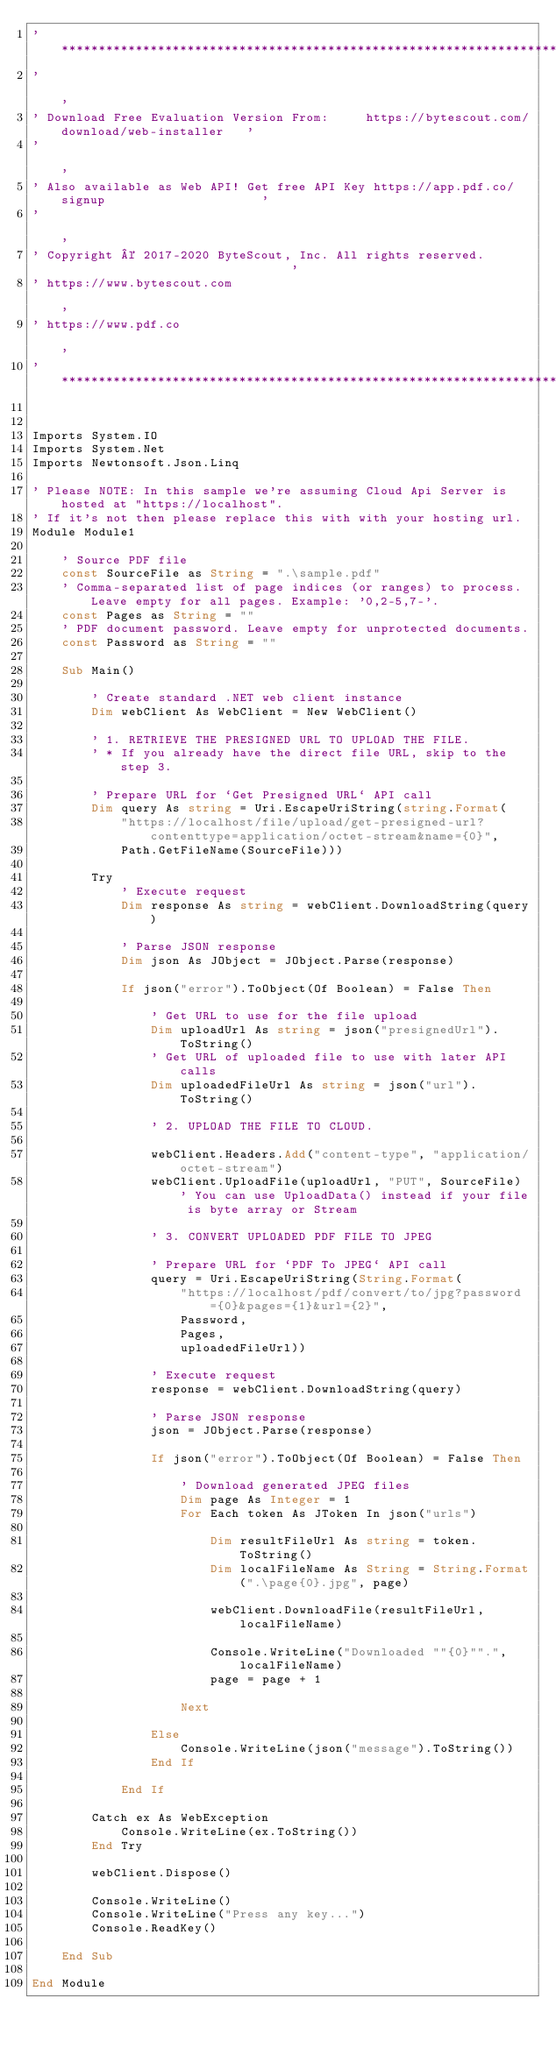Convert code to text. <code><loc_0><loc_0><loc_500><loc_500><_VisualBasic_>'*******************************************************************************************'
'                                                                                           '
' Download Free Evaluation Version From:     https://bytescout.com/download/web-installer   '
'                                                                                           '
' Also available as Web API! Get free API Key https://app.pdf.co/signup                     '
'                                                                                           '
' Copyright © 2017-2020 ByteScout, Inc. All rights reserved.                                '
' https://www.bytescout.com                                                                 '
' https://www.pdf.co                                                                        '
'*******************************************************************************************'


Imports System.IO
Imports System.Net
Imports Newtonsoft.Json.Linq

' Please NOTE: In this sample we're assuming Cloud Api Server is hosted at "https://localhost". 
' If it's not then please replace this with with your hosting url.
Module Module1

 	' Source PDF file
	const SourceFile as String = ".\sample.pdf"
	' Comma-separated list of page indices (or ranges) to process. Leave empty for all pages. Example: '0,2-5,7-'.
	const Pages as String = ""
	' PDF document password. Leave empty for unprotected documents.
	const Password as String = ""
	
	Sub Main()

		' Create standard .NET web client instance
		Dim webClient As WebClient = New WebClient()

		' 1. RETRIEVE THE PRESIGNED URL TO UPLOAD THE FILE.
		' * If you already have the direct file URL, skip to the step 3.

		' Prepare URL for `Get Presigned URL` API call
		Dim query As string = Uri.EscapeUriString(string.Format(
			"https://localhost/file/upload/get-presigned-url?contenttype=application/octet-stream&name={0}", 
			Path.GetFileName(SourceFile)))

		Try
			' Execute request
			Dim response As string = webClient.DownloadString(query)

			' Parse JSON response
			Dim json As JObject = JObject.Parse(response)

			If json("error").ToObject(Of Boolean) = False Then

				' Get URL to use for the file upload
				Dim uploadUrl As string = json("presignedUrl").ToString()
				' Get URL of uploaded file to use with later API calls
				Dim uploadedFileUrl As string = json("url").ToString()

				' 2. UPLOAD THE FILE TO CLOUD.

				webClient.Headers.Add("content-type", "application/octet-stream")
				webClient.UploadFile(uploadUrl, "PUT", SourceFile) ' You can use UploadData() instead if your file is byte array or Stream
				
				' 3. CONVERT UPLOADED PDF FILE TO JPEG

				' Prepare URL for `PDF To JPEG` API call
				query = Uri.EscapeUriString(String.Format(
					"https://localhost/pdf/convert/to/jpg?password={0}&pages={1}&url={2}",
					Password,
					Pages,
					uploadedFileUrl))

				' Execute request
				response = webClient.DownloadString(query)

				' Parse JSON response
				json = JObject.Parse(response)

				If json("error").ToObject(Of Boolean) = False Then
				
					' Download generated JPEG files
					Dim page As Integer = 1
					For Each token As JToken In json("urls")
					
						Dim resultFileUrl As string = token.ToString()
						Dim localFileName As String = String.Format(".\page{0}.jpg", page)

						webClient.DownloadFile(resultFileUrl, localFileName)

						Console.WriteLine("Downloaded ""{0}"".", localFileName)
						page = page + 1

					Next

				Else 
					Console.WriteLine(json("message").ToString())
				End If

			End If
			
		Catch ex As WebException
			Console.WriteLine(ex.ToString())
		End Try

		webClient.Dispose()

		Console.WriteLine()
		Console.WriteLine("Press any key...")
		Console.ReadKey()

	End Sub

End Module
</code> 